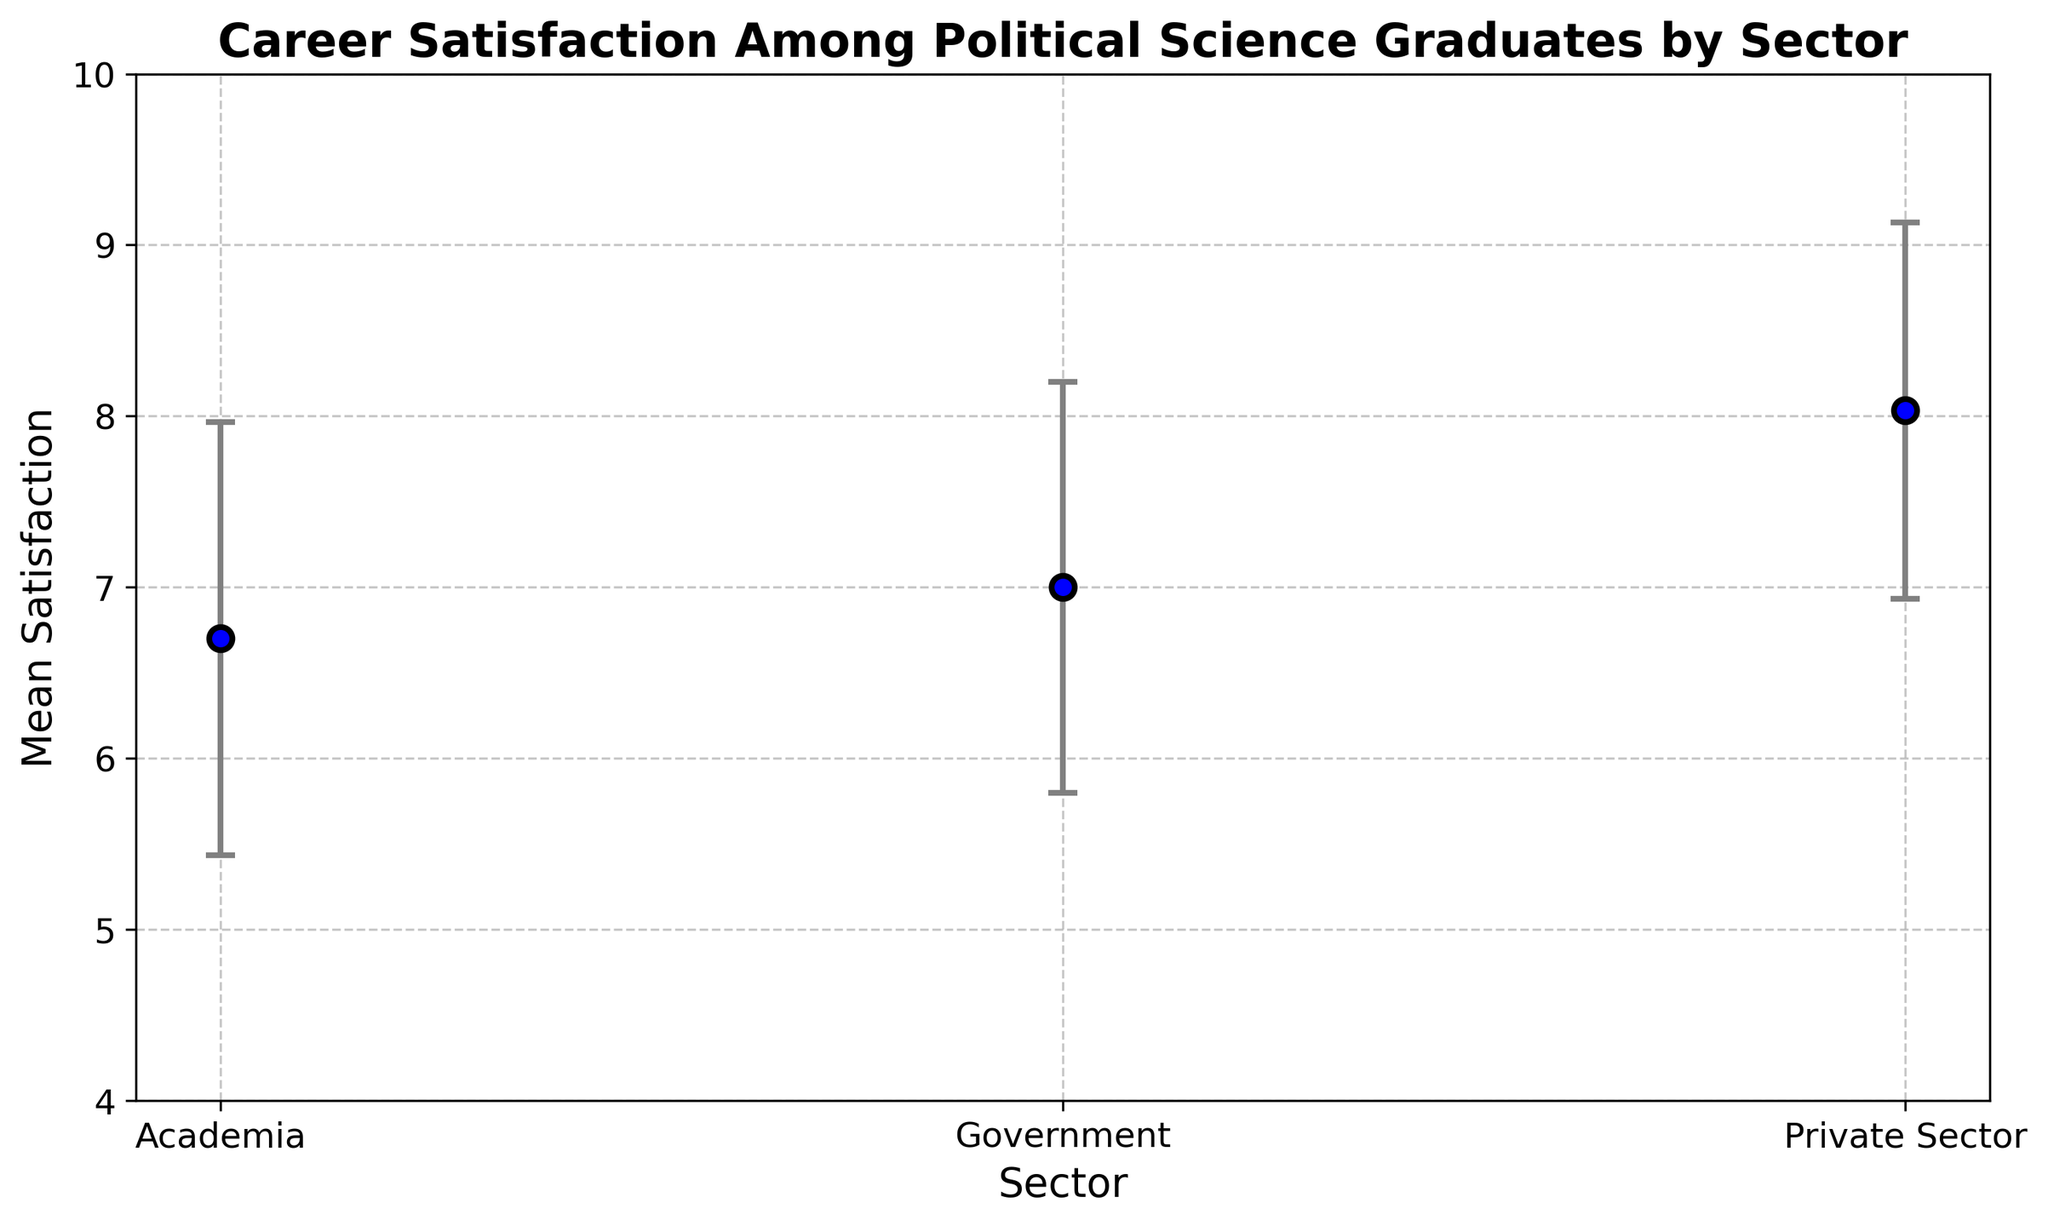What's the average mean career satisfaction across all sectors? First find the mean career satisfaction for each sector: Government (7.0), Academia (6.7), and Private Sector (8.03). Sum these means, then divide by the number of sectors (3). (7.0 + 6.7 + 8.03) / 3 = 21.73 / 3 = 7.243
Answer: 7.24 Which sector has the highest variability in career satisfaction? Look at the standard deviation for each sector. Government (1.2), Academia (1.27), and Private Sector (1.1). Academia has the highest standard deviation, indicating the most variability.
Answer: Academia How does the career satisfaction in Government compare to that in Academia? Government has a mean satisfaction of 7.0, while Academia has a mean satisfaction of 6.7. Thus, satisfaction in Government is higher.
Answer: Government is higher What is the difference in mean career satisfaction between the Private Sector and Academia? Subtract the mean satisfaction of Academia (6.7) from that of the Private Sector (8.03). 8.03 - 6.7 = 1.33
Answer: 1.33 Which sector has the most consistent (least variable) career satisfaction, and how can you tell? Look at the standard deviations given. The sector with the smallest standard deviation indicates the least variability. Government (1.2), Academia (1.27), Private Sector (1.1). The Private Sector has the smallest standard deviation.
Answer: Private Sector What can you infer about career satisfaction in the Private Sector compared to Government, in terms of both mean and variability? The Private Sector has a higher mean satisfaction (8.03) than Government (7.0), and it also has lower variability (standard deviation of 1.1 vs. Government's 1.2).
Answer: Higher mean and lower variability If a new graduate wanted the highest certainty in their career satisfaction level, which sector would you recommend? Recommend the sector with the lowest standard deviation, indicating the most consistent career satisfaction. This is the Private Sector with a standard deviation of 1.1.
Answer: Private Sector Considering both the mean and variability, which sector offers the best overall career satisfaction? The Private Sector has the highest mean satisfaction (8.03) and the lowest variability (standard deviation of 1.1), making it the best overall.
Answer: Private Sector What is the visual cue that helps to identify the sector with the highest mean career satisfaction? The mean satisfaction value for the Private Sector is plotted highest on the y-axis. The visual cue is the highest marker on the chart.
Answer: Highest point on y-axis Given the plotted error bars, which sector's career satisfaction estimates are the most spread out? The length of the error bars represents the standard deviation. Academia has the longest error bars, indicating the most spread-out estimates.
Answer: Academia 